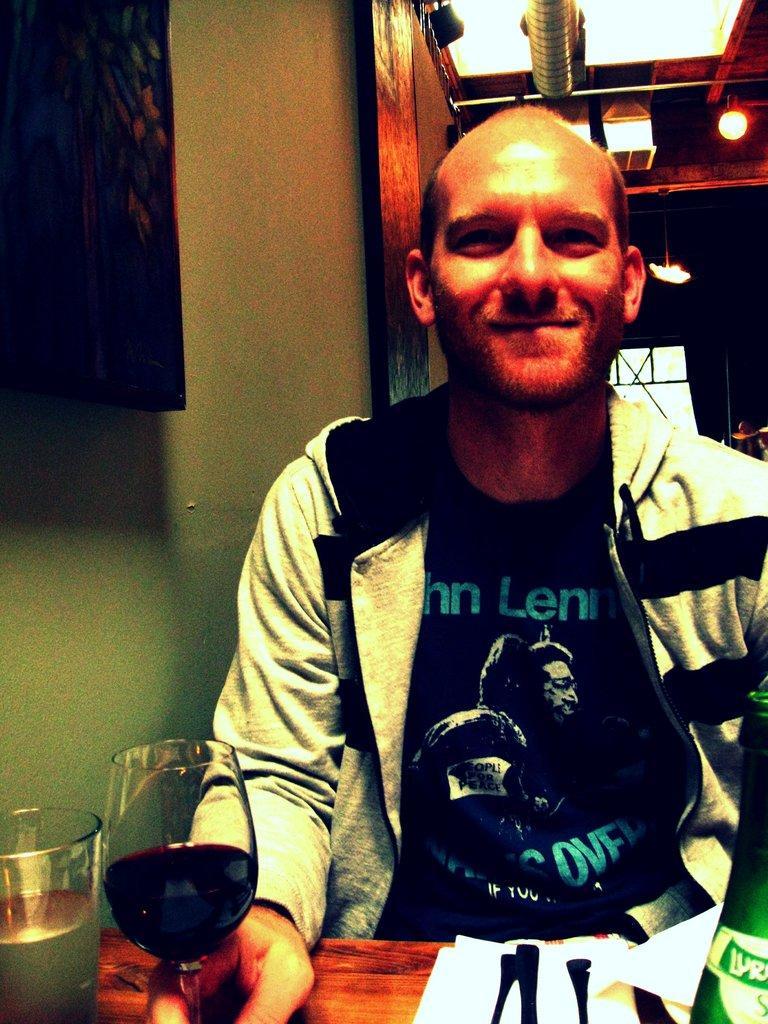Can you describe this image briefly? In this image, There is a table which is in yellow color on that table there are some glasses and there is a man sitting on the chair and he is smiling, In the left side there is a wall which is in green color. 